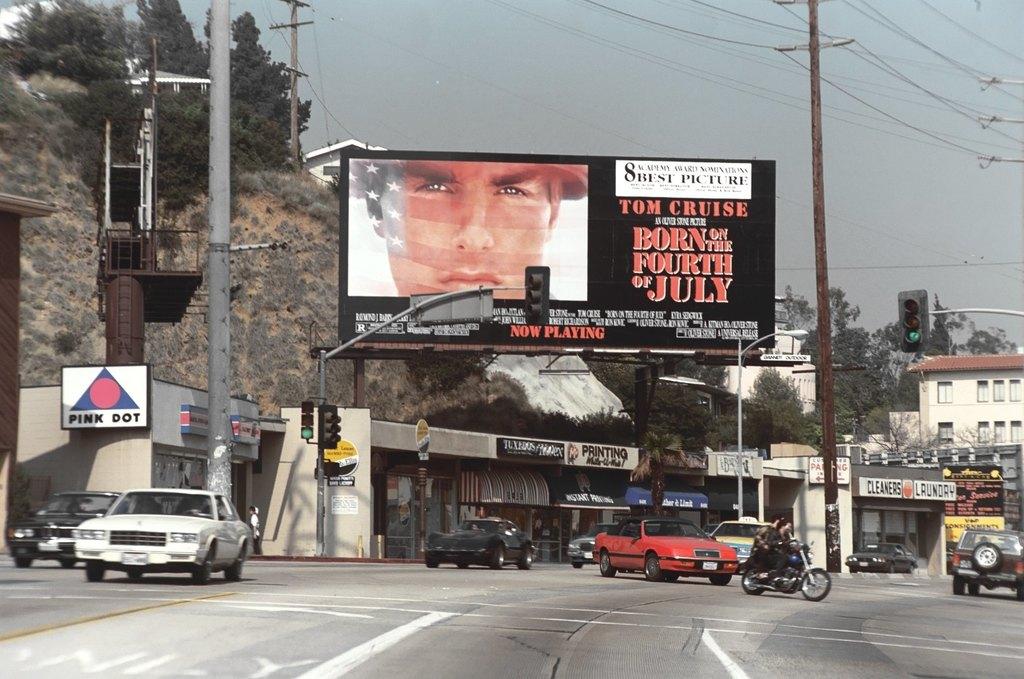What actor is on the billboard?
Provide a short and direct response. Tom cruise. What is the tom cruise movie being advertised?
Your response must be concise. Born on the fourth of july. 